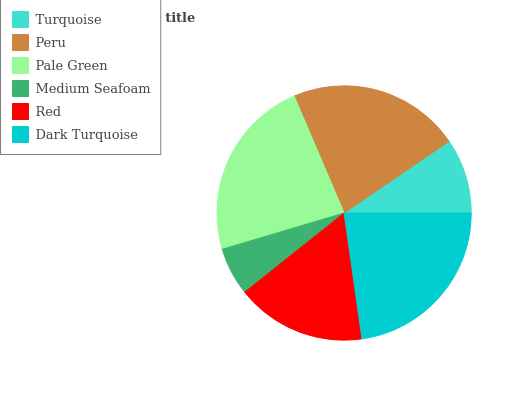Is Medium Seafoam the minimum?
Answer yes or no. Yes. Is Pale Green the maximum?
Answer yes or no. Yes. Is Peru the minimum?
Answer yes or no. No. Is Peru the maximum?
Answer yes or no. No. Is Peru greater than Turquoise?
Answer yes or no. Yes. Is Turquoise less than Peru?
Answer yes or no. Yes. Is Turquoise greater than Peru?
Answer yes or no. No. Is Peru less than Turquoise?
Answer yes or no. No. Is Peru the high median?
Answer yes or no. Yes. Is Red the low median?
Answer yes or no. Yes. Is Pale Green the high median?
Answer yes or no. No. Is Dark Turquoise the low median?
Answer yes or no. No. 